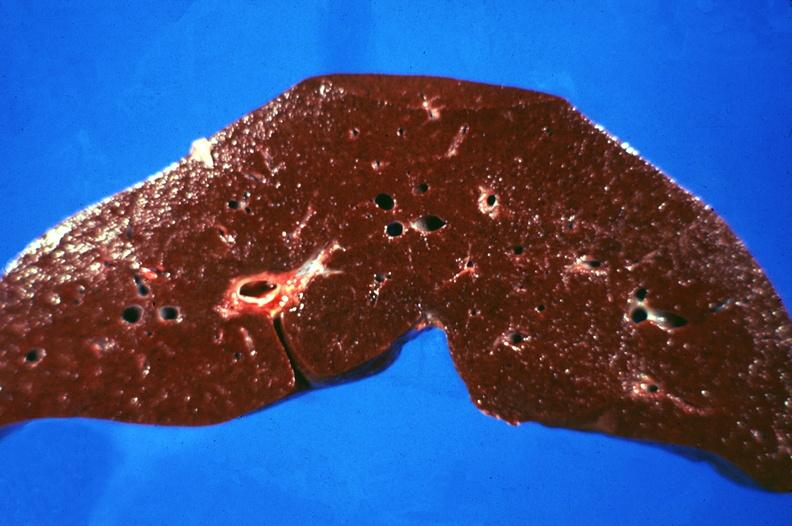s sacrococcygeal teratoma present?
Answer the question using a single word or phrase. No 